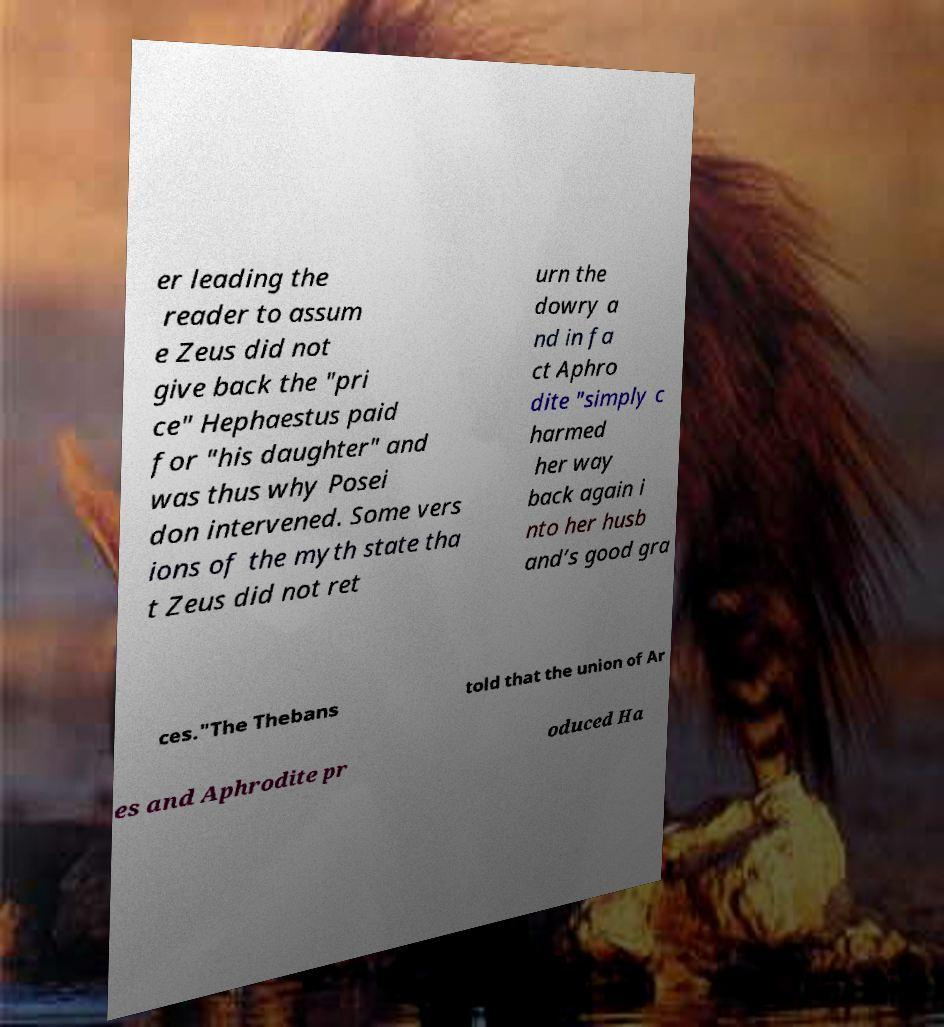I need the written content from this picture converted into text. Can you do that? er leading the reader to assum e Zeus did not give back the "pri ce" Hephaestus paid for "his daughter" and was thus why Posei don intervened. Some vers ions of the myth state tha t Zeus did not ret urn the dowry a nd in fa ct Aphro dite "simply c harmed her way back again i nto her husb and’s good gra ces."The Thebans told that the union of Ar es and Aphrodite pr oduced Ha 